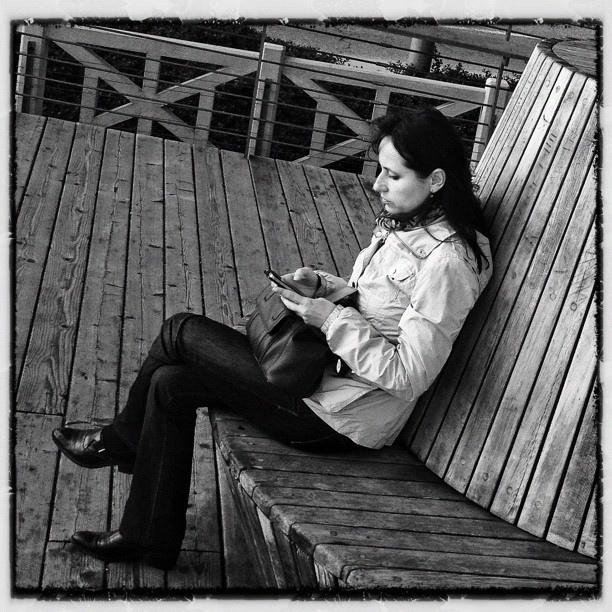Is the woman happy?
Write a very short answer. No. What color is the photo?
Keep it brief. Black and white. What is the woman looking at in the picture?
Be succinct. Phone. 